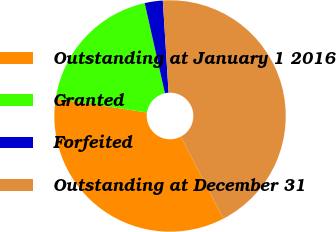<chart> <loc_0><loc_0><loc_500><loc_500><pie_chart><fcel>Outstanding at January 1 2016<fcel>Granted<fcel>Forfeited<fcel>Outstanding at December 31<nl><fcel>35.03%<fcel>19.09%<fcel>2.52%<fcel>43.36%<nl></chart> 